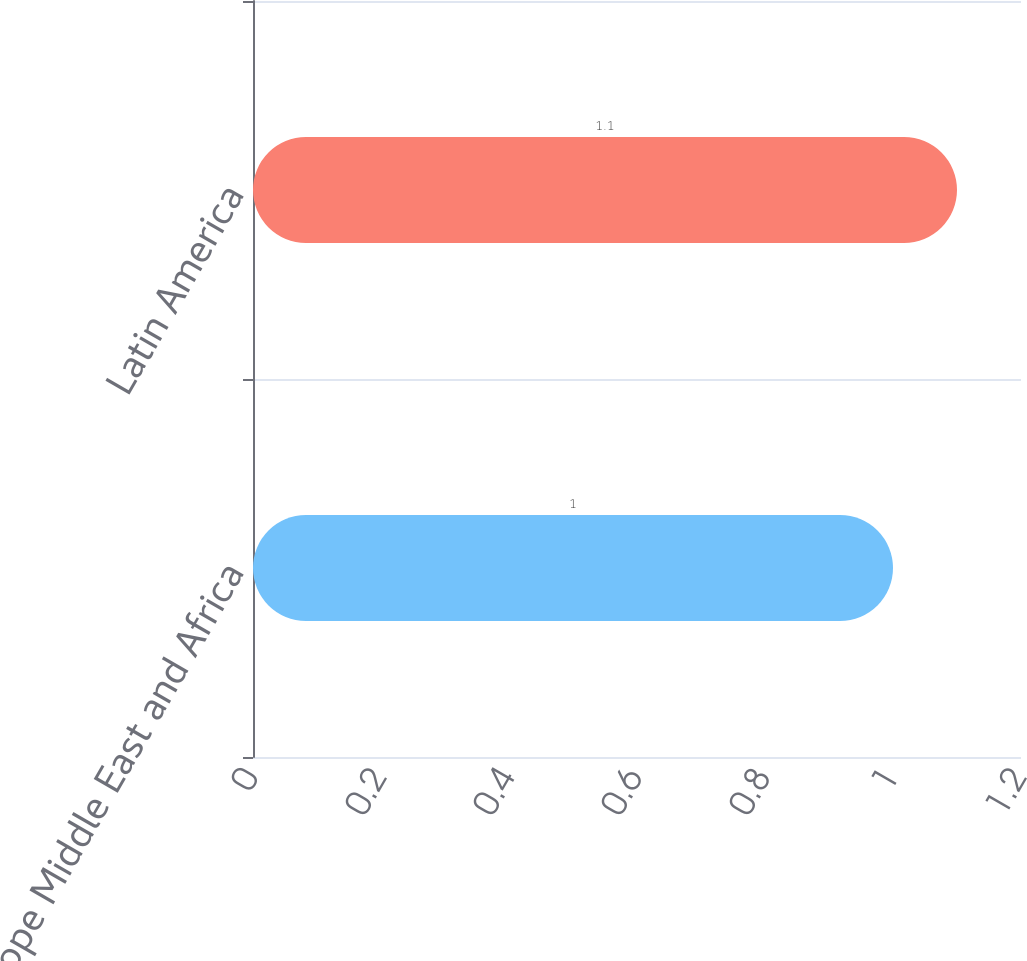Convert chart. <chart><loc_0><loc_0><loc_500><loc_500><bar_chart><fcel>Europe Middle East and Africa<fcel>Latin America<nl><fcel>1<fcel>1.1<nl></chart> 